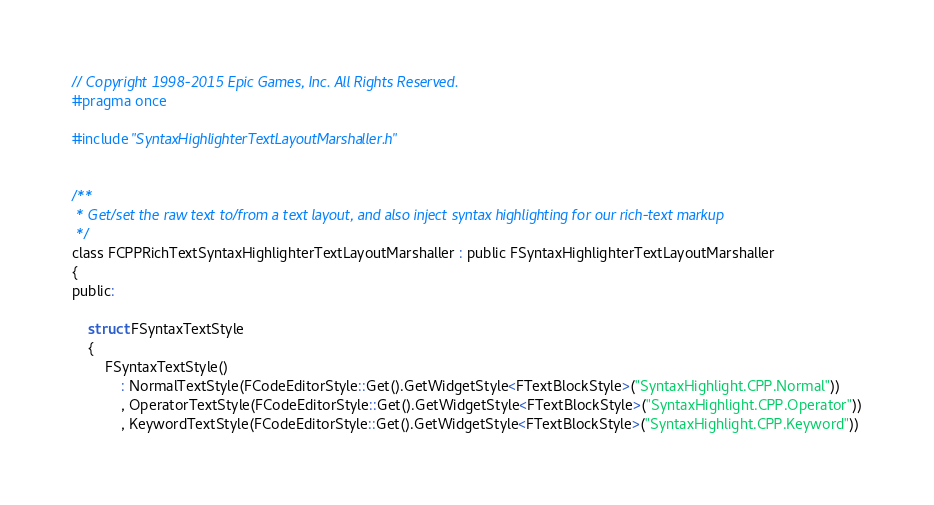<code> <loc_0><loc_0><loc_500><loc_500><_C_>// Copyright 1998-2015 Epic Games, Inc. All Rights Reserved.
#pragma once

#include "SyntaxHighlighterTextLayoutMarshaller.h"


/**
 * Get/set the raw text to/from a text layout, and also inject syntax highlighting for our rich-text markup
 */
class FCPPRichTextSyntaxHighlighterTextLayoutMarshaller : public FSyntaxHighlighterTextLayoutMarshaller
{
public:

	struct FSyntaxTextStyle
	{
		FSyntaxTextStyle()
			: NormalTextStyle(FCodeEditorStyle::Get().GetWidgetStyle<FTextBlockStyle>("SyntaxHighlight.CPP.Normal"))
			, OperatorTextStyle(FCodeEditorStyle::Get().GetWidgetStyle<FTextBlockStyle>("SyntaxHighlight.CPP.Operator"))
			, KeywordTextStyle(FCodeEditorStyle::Get().GetWidgetStyle<FTextBlockStyle>("SyntaxHighlight.CPP.Keyword"))</code> 